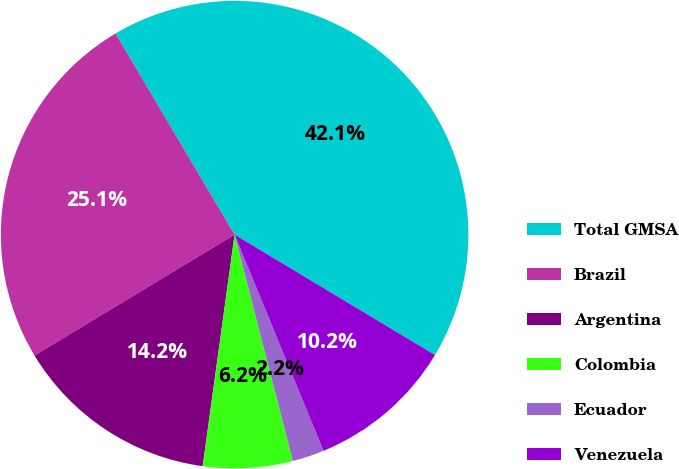Convert chart to OTSL. <chart><loc_0><loc_0><loc_500><loc_500><pie_chart><fcel>Total GMSA<fcel>Brazil<fcel>Argentina<fcel>Colombia<fcel>Ecuador<fcel>Venezuela<nl><fcel>42.12%<fcel>25.14%<fcel>14.17%<fcel>6.19%<fcel>2.2%<fcel>10.18%<nl></chart> 